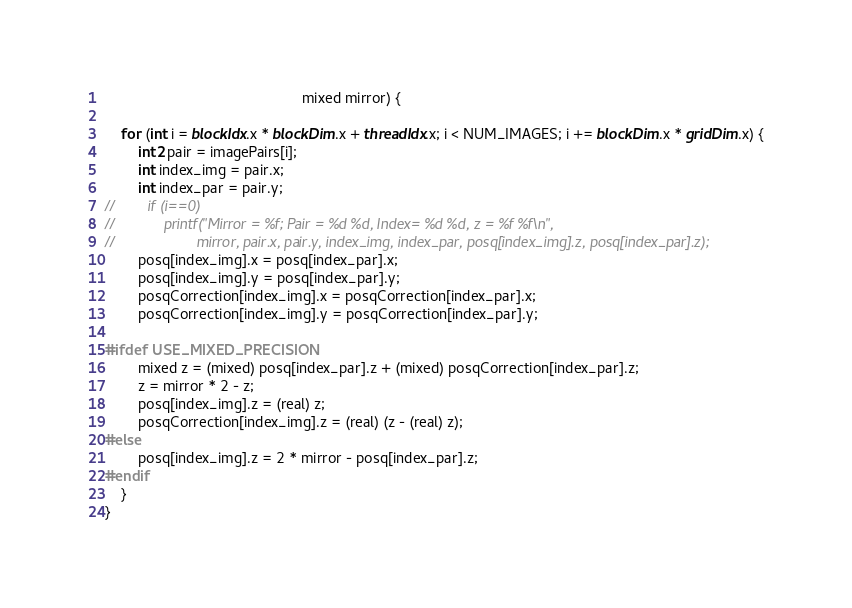<code> <loc_0><loc_0><loc_500><loc_500><_Cuda_>                                                mixed mirror) {

    for (int i = blockIdx.x * blockDim.x + threadIdx.x; i < NUM_IMAGES; i += blockDim.x * gridDim.x) {
        int2 pair = imagePairs[i];
        int index_img = pair.x;
        int index_par = pair.y;
//        if (i==0)
//            printf("Mirror = %f; Pair = %d %d, Index= %d %d, z = %f %f\n",
//                    mirror, pair.x, pair.y, index_img, index_par, posq[index_img].z, posq[index_par].z);
        posq[index_img].x = posq[index_par].x;
        posq[index_img].y = posq[index_par].y;
        posqCorrection[index_img].x = posqCorrection[index_par].x;
        posqCorrection[index_img].y = posqCorrection[index_par].y;

#ifdef USE_MIXED_PRECISION
        mixed z = (mixed) posq[index_par].z + (mixed) posqCorrection[index_par].z;
        z = mirror * 2 - z;
        posq[index_img].z = (real) z;
        posqCorrection[index_img].z = (real) (z - (real) z);
#else
        posq[index_img].z = 2 * mirror - posq[index_par].z;
#endif
    }
}
</code> 